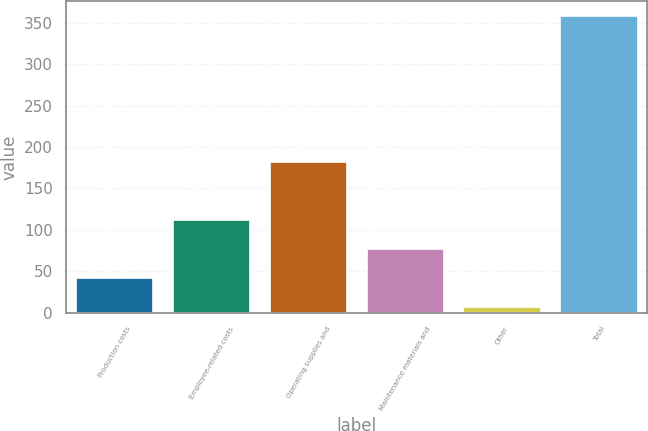Convert chart to OTSL. <chart><loc_0><loc_0><loc_500><loc_500><bar_chart><fcel>Production costs<fcel>Employee-related costs<fcel>Operating supplies and<fcel>Maintenance materials and<fcel>Other<fcel>Total<nl><fcel>42.1<fcel>112.3<fcel>182<fcel>77.2<fcel>7<fcel>358<nl></chart> 